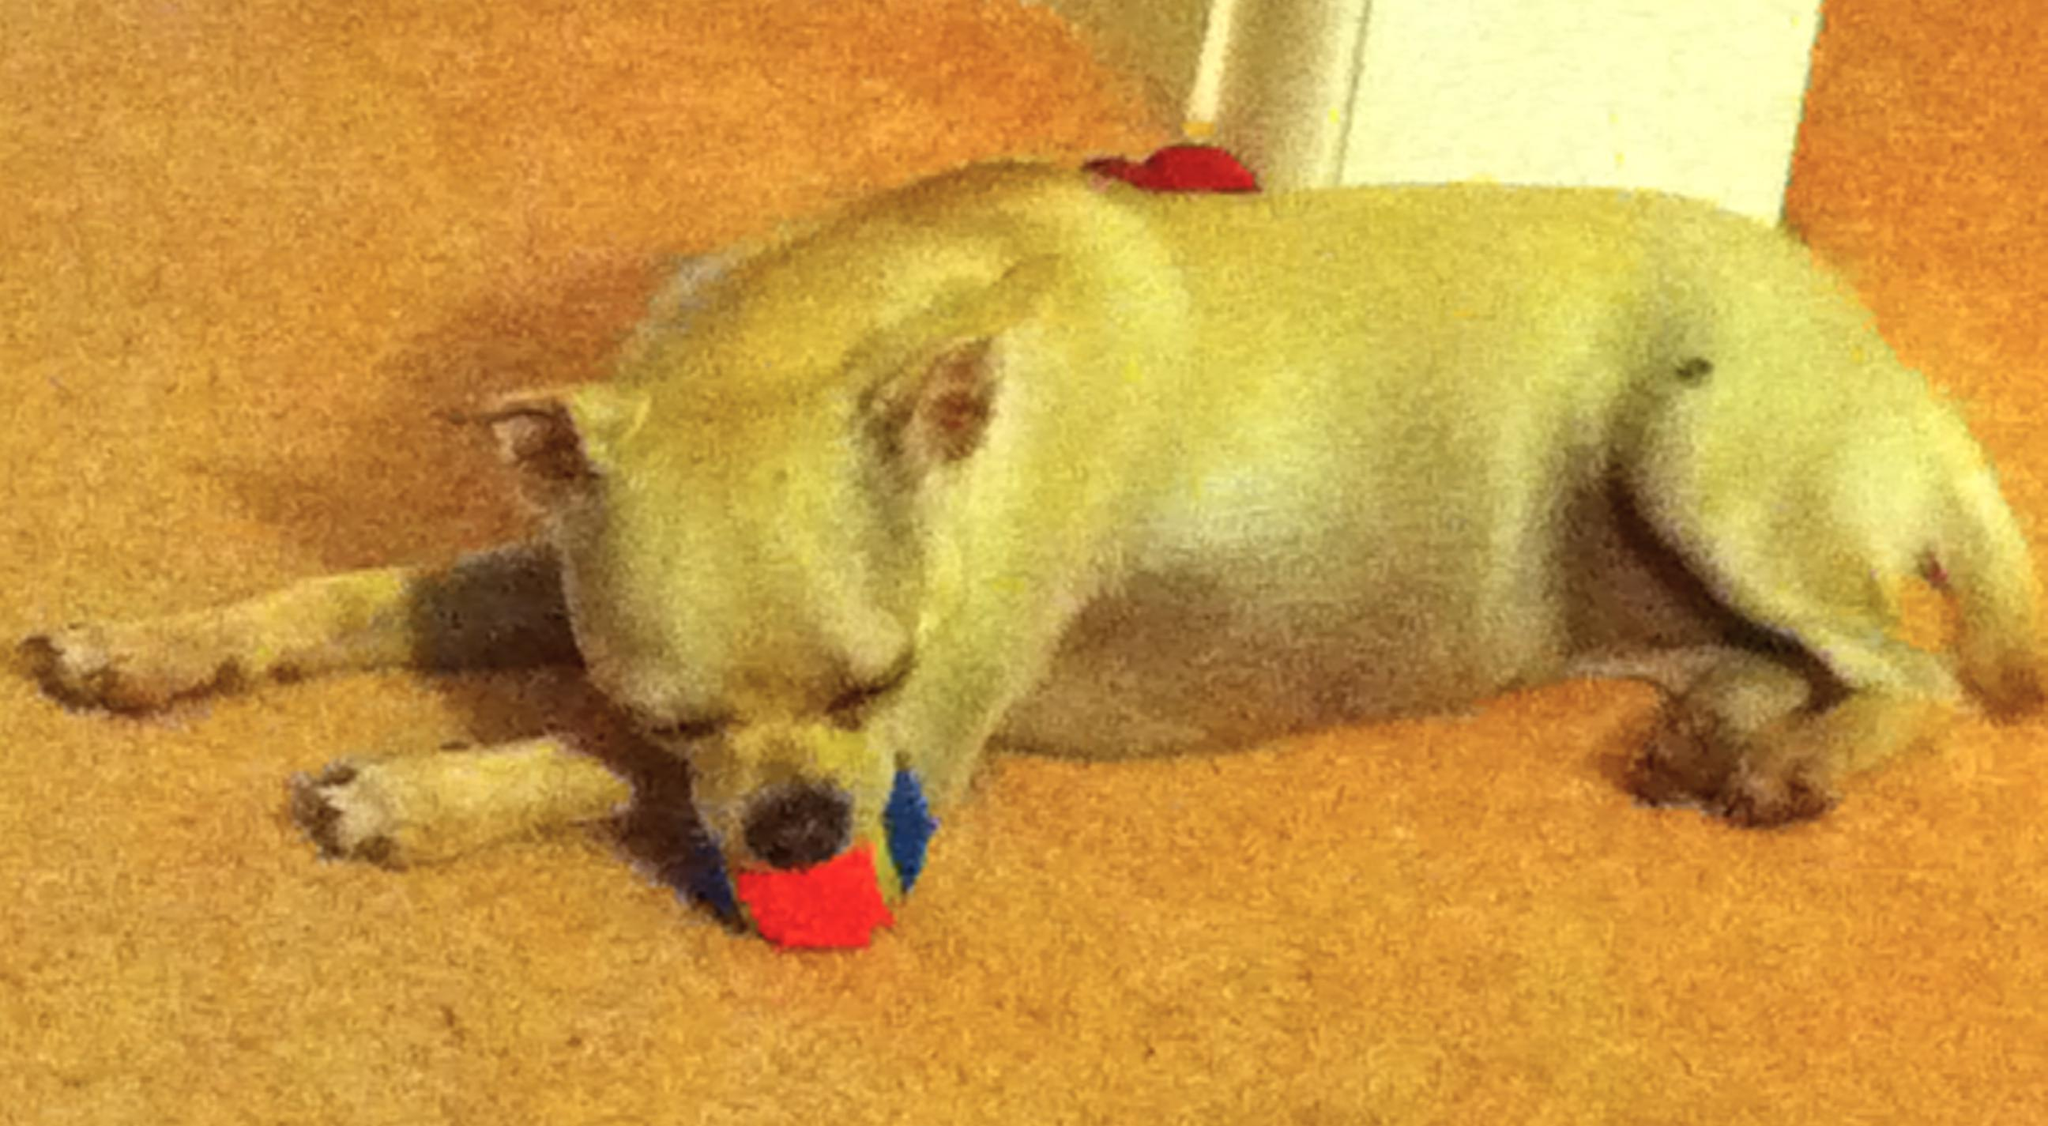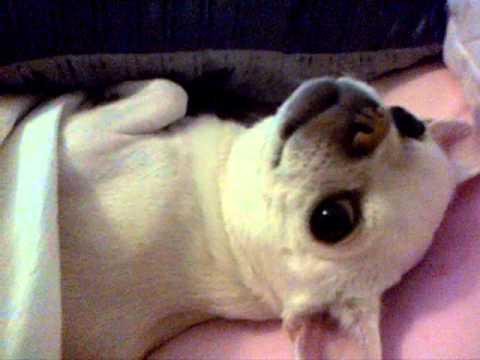The first image is the image on the left, the second image is the image on the right. Analyze the images presented: Is the assertion "Three dogs are lying down sleeping." valid? Answer yes or no. No. The first image is the image on the left, the second image is the image on the right. Given the left and right images, does the statement "All chihuahuas appear to be sleeping, and one image contains twice as many chihuahuas as the other image." hold true? Answer yes or no. No. 